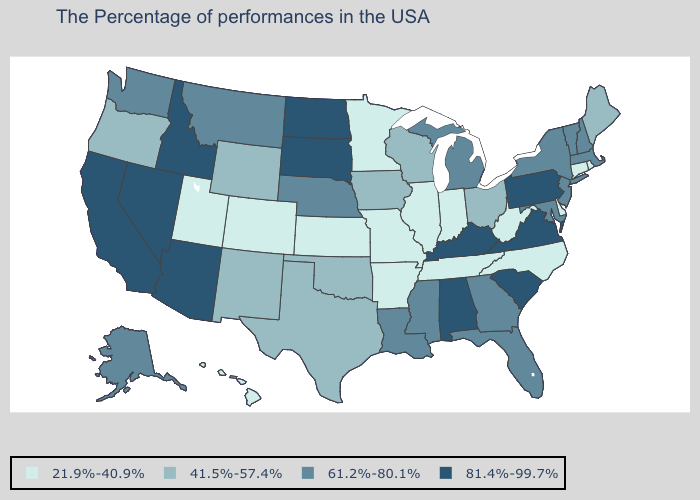Does New Mexico have the highest value in the West?
Keep it brief. No. Does the map have missing data?
Write a very short answer. No. Which states have the lowest value in the USA?
Be succinct. Rhode Island, Connecticut, Delaware, North Carolina, West Virginia, Indiana, Tennessee, Illinois, Missouri, Arkansas, Minnesota, Kansas, Colorado, Utah, Hawaii. What is the value of Indiana?
Concise answer only. 21.9%-40.9%. What is the lowest value in the South?
Write a very short answer. 21.9%-40.9%. Name the states that have a value in the range 41.5%-57.4%?
Write a very short answer. Maine, Ohio, Wisconsin, Iowa, Oklahoma, Texas, Wyoming, New Mexico, Oregon. Does the first symbol in the legend represent the smallest category?
Be succinct. Yes. What is the value of Connecticut?
Quick response, please. 21.9%-40.9%. What is the highest value in the USA?
Quick response, please. 81.4%-99.7%. Name the states that have a value in the range 21.9%-40.9%?
Answer briefly. Rhode Island, Connecticut, Delaware, North Carolina, West Virginia, Indiana, Tennessee, Illinois, Missouri, Arkansas, Minnesota, Kansas, Colorado, Utah, Hawaii. Does Florida have the lowest value in the USA?
Answer briefly. No. What is the lowest value in states that border Connecticut?
Answer briefly. 21.9%-40.9%. What is the lowest value in the USA?
Quick response, please. 21.9%-40.9%. Does California have the highest value in the West?
Short answer required. Yes. Among the states that border Louisiana , does Arkansas have the lowest value?
Write a very short answer. Yes. 